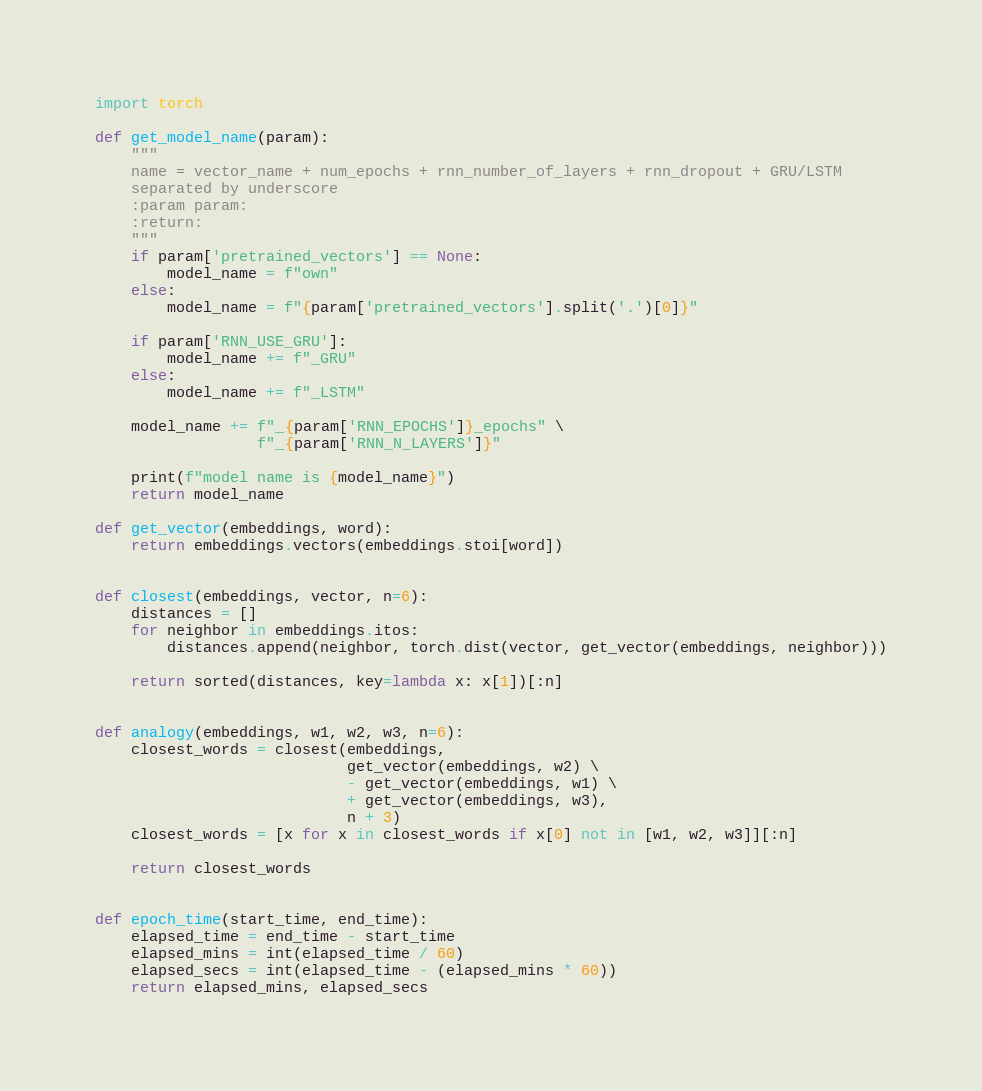<code> <loc_0><loc_0><loc_500><loc_500><_Python_>import torch

def get_model_name(param):
    """
    name = vector_name + num_epochs + rnn_number_of_layers + rnn_dropout + GRU/LSTM
    separated by underscore
    :param param:
    :return:
    """
    if param['pretrained_vectors'] == None:
        model_name = f"own"
    else:
        model_name = f"{param['pretrained_vectors'].split('.')[0]}"

    if param['RNN_USE_GRU']:
        model_name += f"_GRU"
    else:
        model_name += f"_LSTM"

    model_name += f"_{param['RNN_EPOCHS']}_epochs" \
                  f"_{param['RNN_N_LAYERS']}"

    print(f"model name is {model_name}")
    return model_name

def get_vector(embeddings, word):
    return embeddings.vectors(embeddings.stoi[word])


def closest(embeddings, vector, n=6):
    distances = []
    for neighbor in embeddings.itos:
        distances.append(neighbor, torch.dist(vector, get_vector(embeddings, neighbor)))

    return sorted(distances, key=lambda x: x[1])[:n]


def analogy(embeddings, w1, w2, w3, n=6):
    closest_words = closest(embeddings,
                            get_vector(embeddings, w2) \
                            - get_vector(embeddings, w1) \
                            + get_vector(embeddings, w3),
                            n + 3)
    closest_words = [x for x in closest_words if x[0] not in [w1, w2, w3]][:n]

    return closest_words


def epoch_time(start_time, end_time):
    elapsed_time = end_time - start_time
    elapsed_mins = int(elapsed_time / 60)
    elapsed_secs = int(elapsed_time - (elapsed_mins * 60))
    return elapsed_mins, elapsed_secs
</code> 